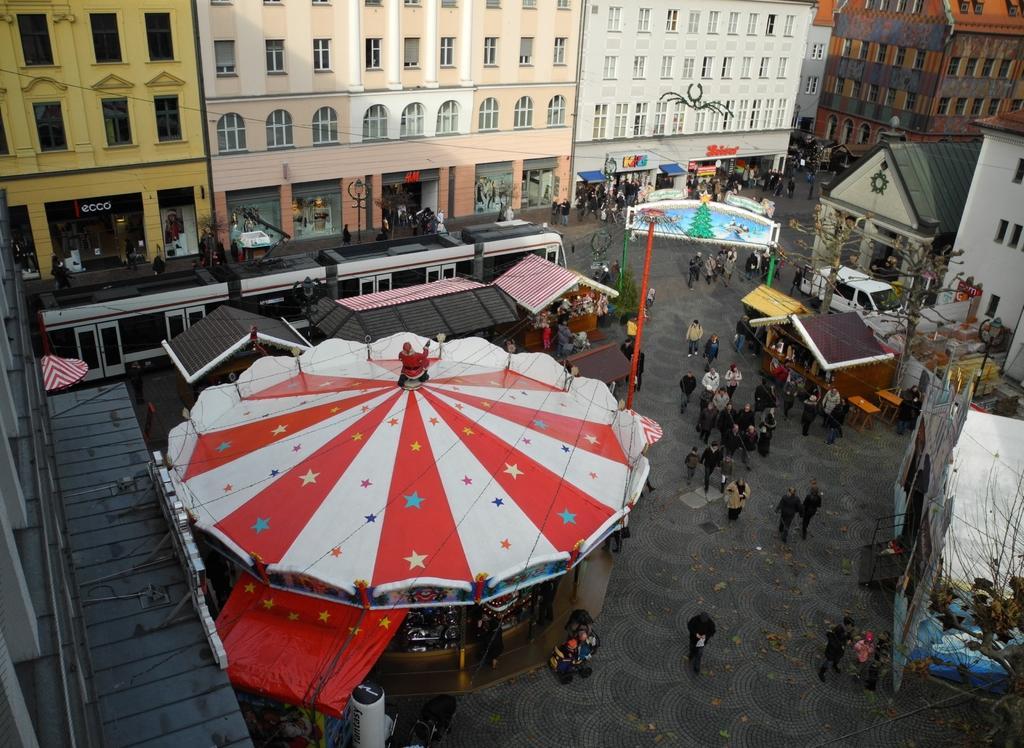How would you summarize this image in a sentence or two? In the picture I can see people are walking on the ground. I can also see buildings, trees, poles, vehicles and some other objects. 